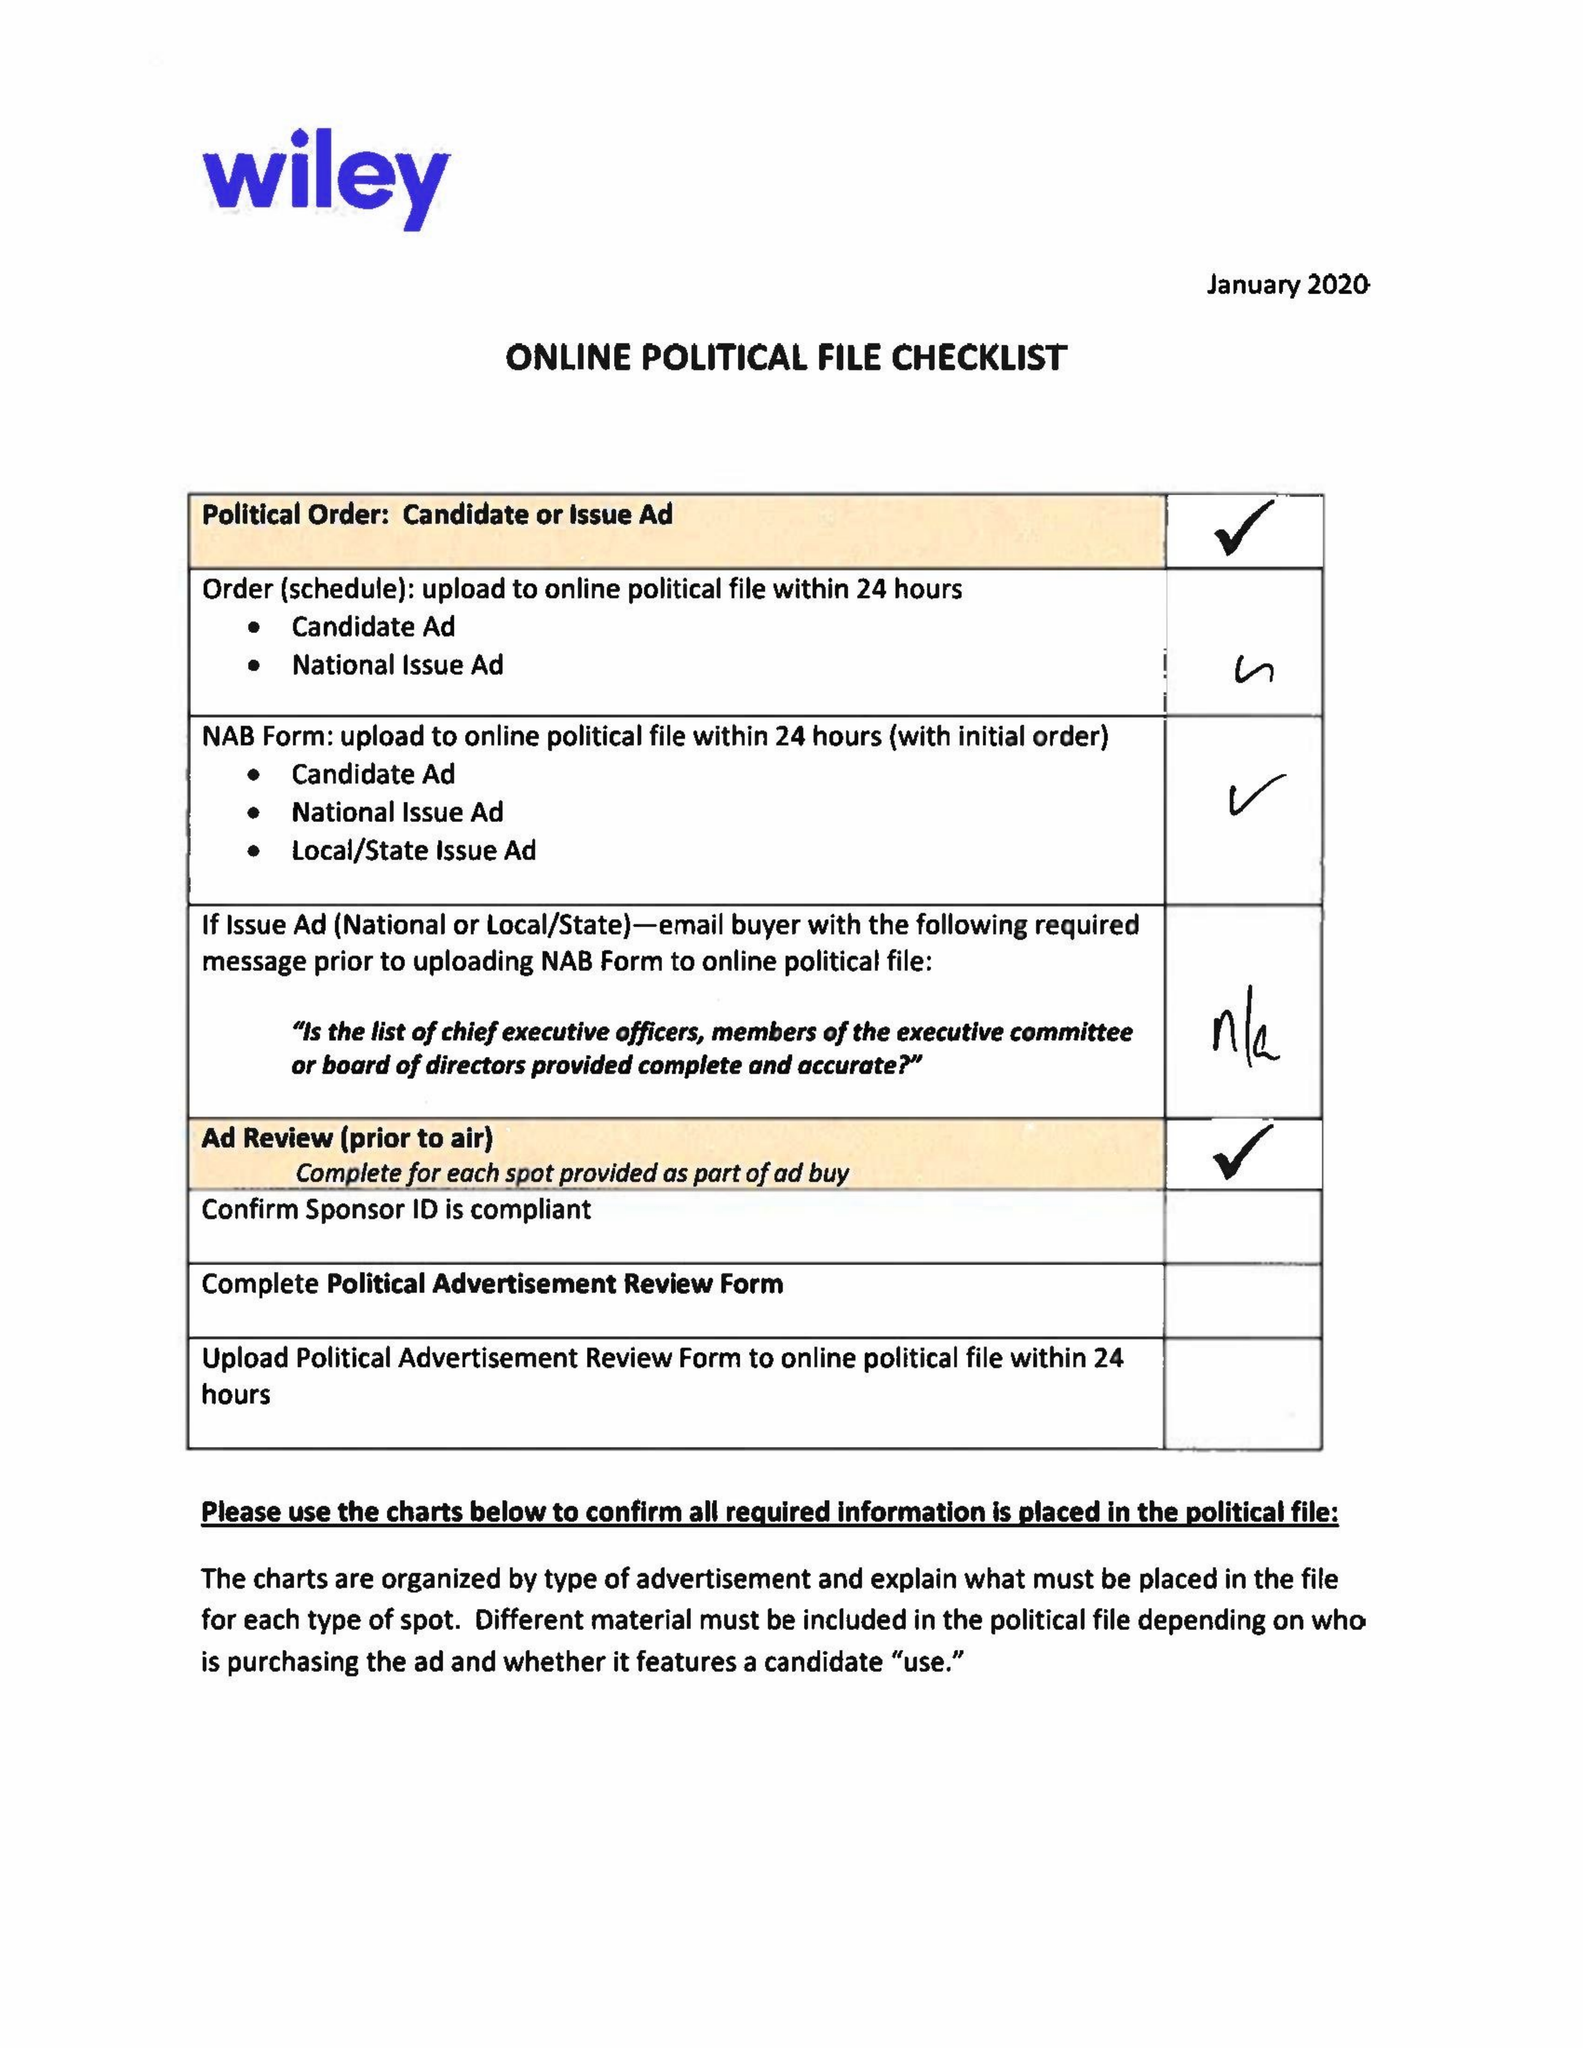What is the value for the contract_num?
Answer the question using a single word or phrase. 1534487 